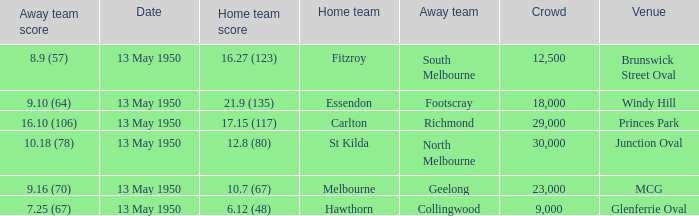What was the lowest crowd size at the Windy Hill venue? 18000.0. 